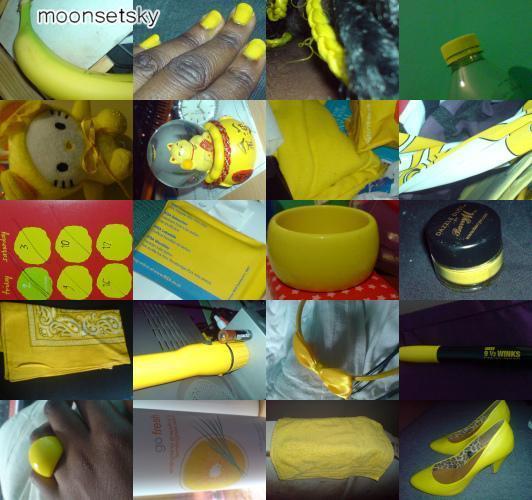How many of the items here have been grown?
Give a very brief answer. 1. How many bottles are in the picture?
Give a very brief answer. 2. How many people can you see?
Give a very brief answer. 2. 